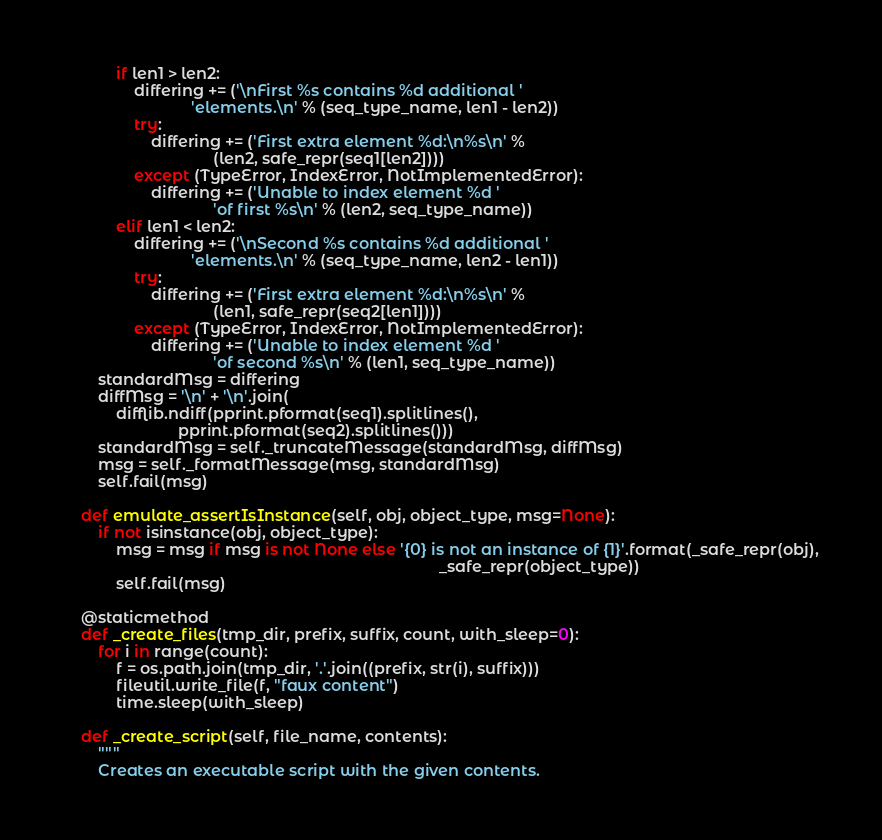<code> <loc_0><loc_0><loc_500><loc_500><_Python_>            if len1 > len2:
                differing += ('\nFirst %s contains %d additional '
                             'elements.\n' % (seq_type_name, len1 - len2))
                try:
                    differing += ('First extra element %d:\n%s\n' %
                                  (len2, safe_repr(seq1[len2])))
                except (TypeError, IndexError, NotImplementedError):
                    differing += ('Unable to index element %d '
                                  'of first %s\n' % (len2, seq_type_name))
            elif len1 < len2:
                differing += ('\nSecond %s contains %d additional '
                             'elements.\n' % (seq_type_name, len2 - len1))
                try:
                    differing += ('First extra element %d:\n%s\n' %
                                  (len1, safe_repr(seq2[len1])))
                except (TypeError, IndexError, NotImplementedError):
                    differing += ('Unable to index element %d '
                                  'of second %s\n' % (len1, seq_type_name))
        standardMsg = differing
        diffMsg = '\n' + '\n'.join(
            difflib.ndiff(pprint.pformat(seq1).splitlines(),
                          pprint.pformat(seq2).splitlines()))
        standardMsg = self._truncateMessage(standardMsg, diffMsg)
        msg = self._formatMessage(msg, standardMsg)
        self.fail(msg)

    def emulate_assertIsInstance(self, obj, object_type, msg=None):
        if not isinstance(obj, object_type):
            msg = msg if msg is not None else '{0} is not an instance of {1}'.format(_safe_repr(obj),
                                                                                     _safe_repr(object_type))
            self.fail(msg)

    @staticmethod
    def _create_files(tmp_dir, prefix, suffix, count, with_sleep=0):
        for i in range(count):
            f = os.path.join(tmp_dir, '.'.join((prefix, str(i), suffix)))
            fileutil.write_file(f, "faux content")
            time.sleep(with_sleep)

    def _create_script(self, file_name, contents):
        """
        Creates an executable script with the given contents.</code> 